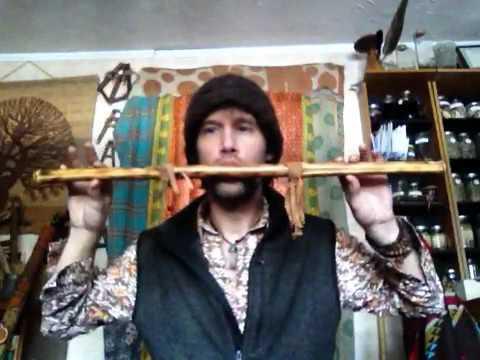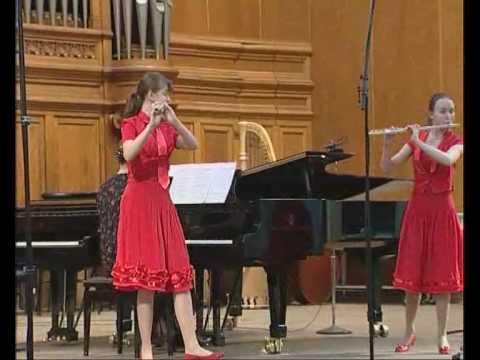The first image is the image on the left, the second image is the image on the right. For the images displayed, is the sentence "One person is playing two instruments at once in the image on the left." factually correct? Answer yes or no. No. 